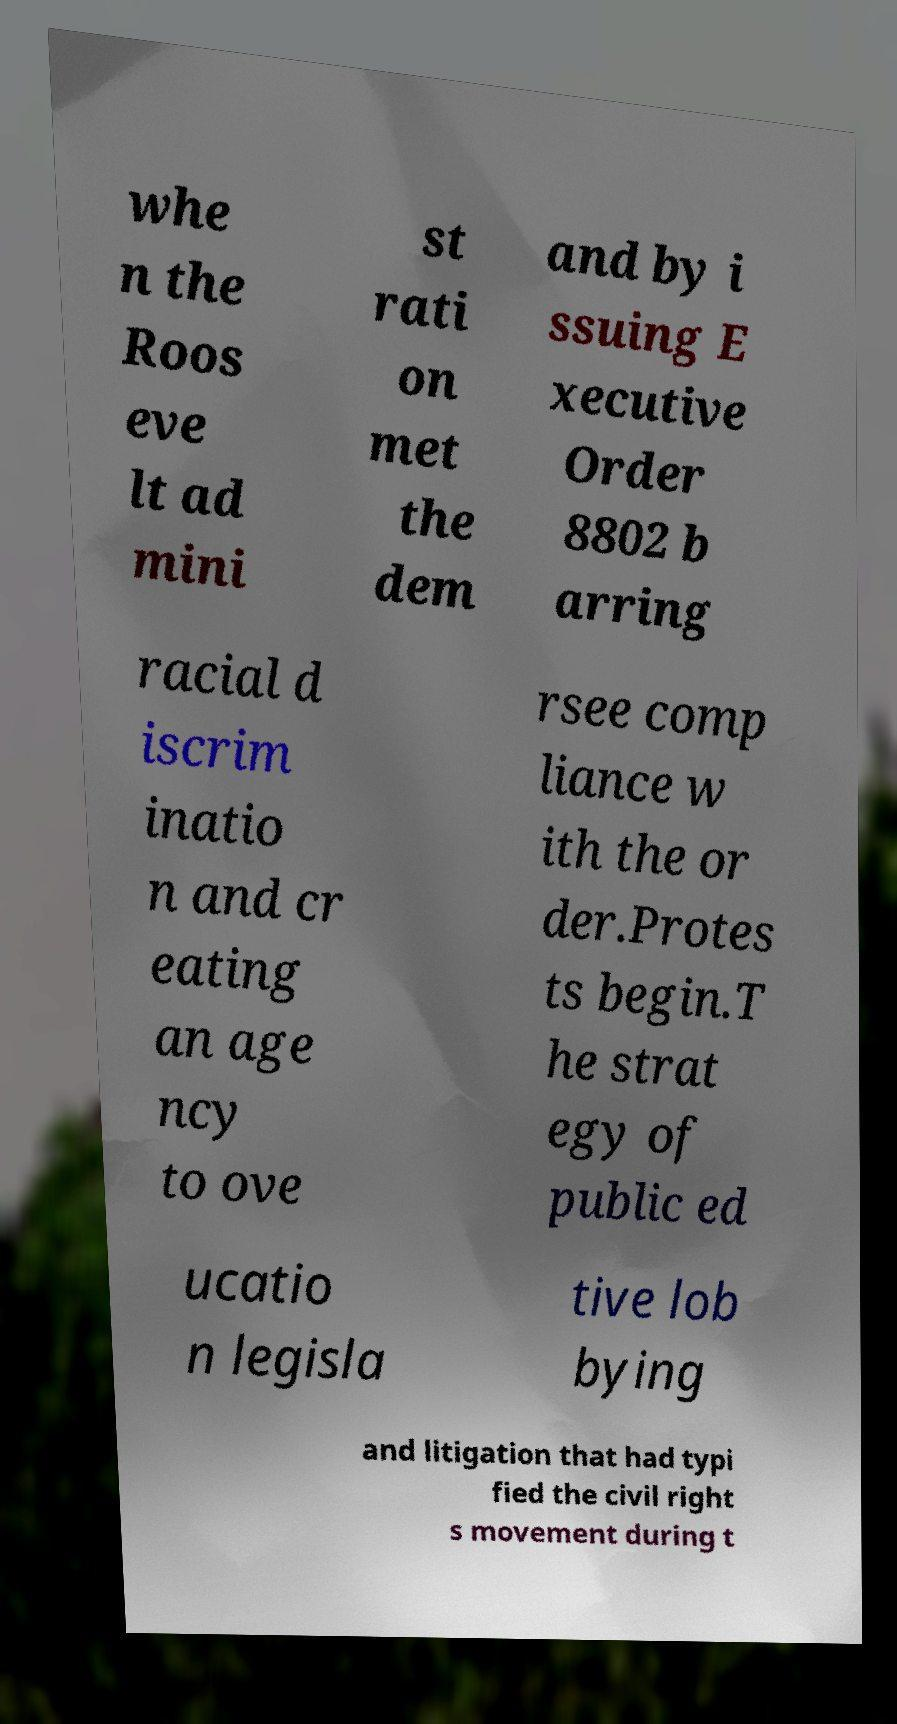Can you accurately transcribe the text from the provided image for me? whe n the Roos eve lt ad mini st rati on met the dem and by i ssuing E xecutive Order 8802 b arring racial d iscrim inatio n and cr eating an age ncy to ove rsee comp liance w ith the or der.Protes ts begin.T he strat egy of public ed ucatio n legisla tive lob bying and litigation that had typi fied the civil right s movement during t 